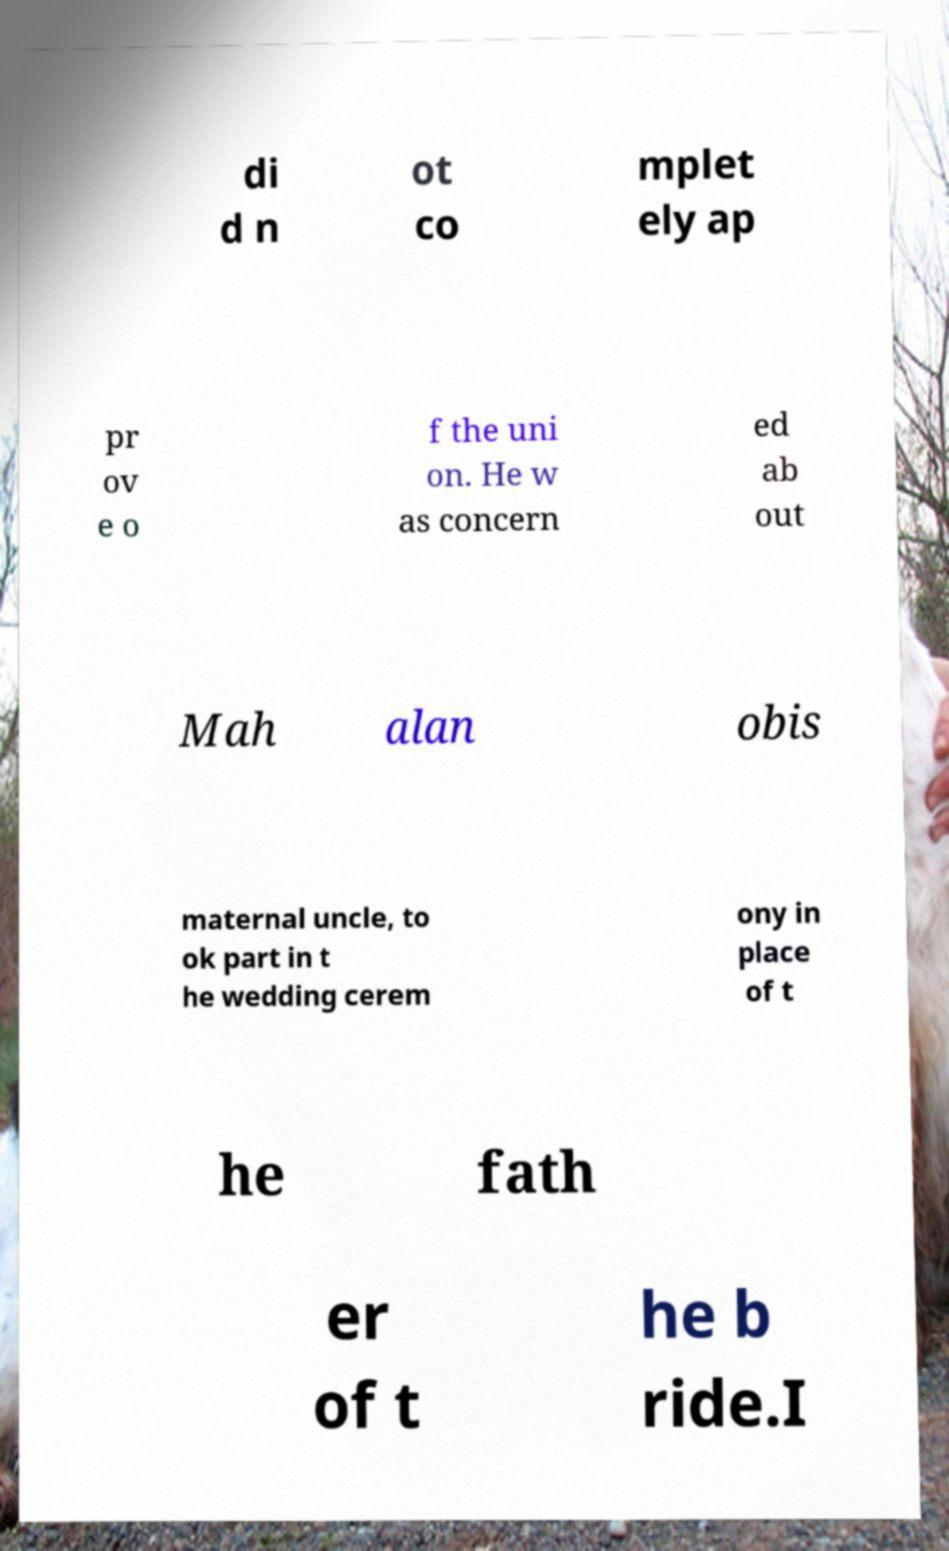Could you assist in decoding the text presented in this image and type it out clearly? di d n ot co mplet ely ap pr ov e o f the uni on. He w as concern ed ab out Mah alan obis maternal uncle, to ok part in t he wedding cerem ony in place of t he fath er of t he b ride.I 